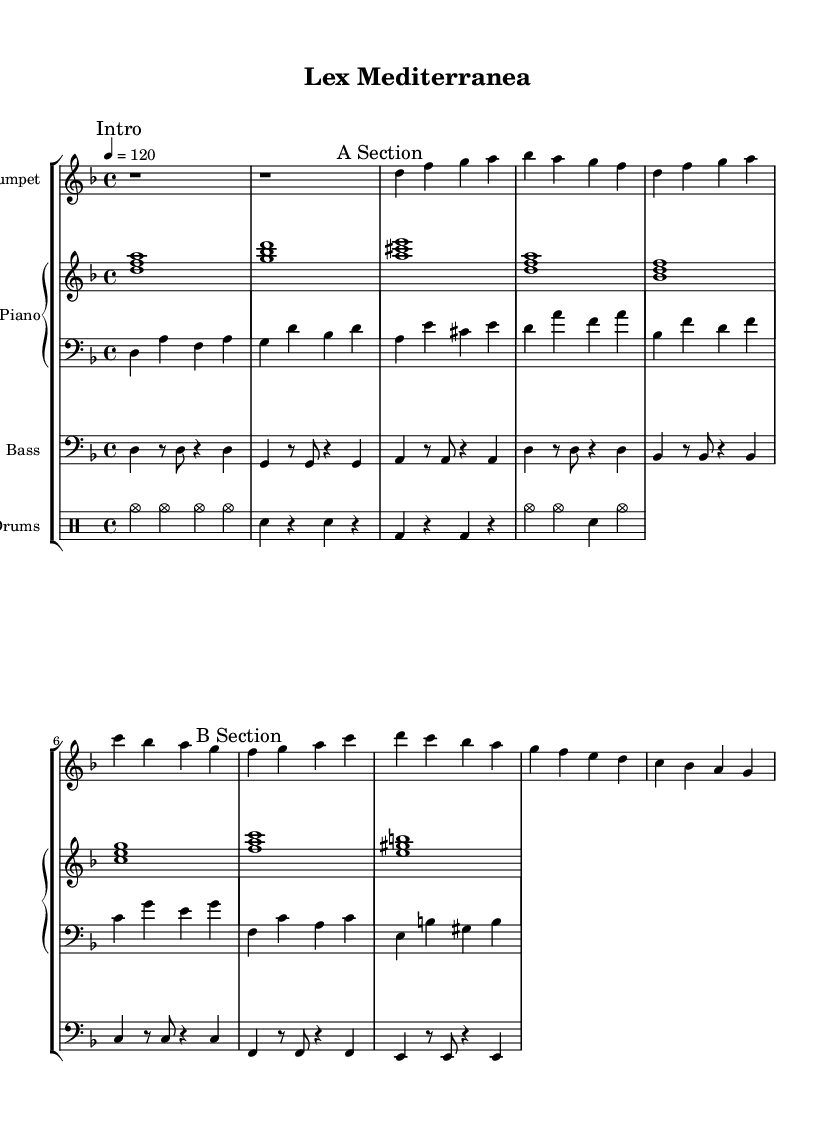What is the key signature of this music? The key signature is indicated by the sharps or flats at the beginning of the staff. In this score, it is determined to be D minor, as there one flat is shown, which corresponds to Bb in D minor.
Answer: D minor What is the time signature of the piece? The time signature is located at the beginning of the score after the key signature. It indicates that there are four beats in each measure, and the quarter note gets one beat. The presence of "4/4" confirms this.
Answer: 4/4 What is the tempo marking for this piece? The tempo marking is found above the staff, stating the speed of the piece. It indicates "4 = 120," which refers to the metronome marking of 120 beats per minute.
Answer: 120 How many measures are there in the A Section? The A Section starts after the intro and consists of a sequence of notes from the first measure labeled with "A Section" through the last measure before the "B Section." Counting these gives us a total of four measures.
Answer: 4 What is the primary rhythm pattern used in the drums part? The drums part uses cymbal hits consistently throughout the measures, indicating a steady rhythm. Notably, the counting of the first measure shows a pattern where cymbals are played on every beat. Thus, it can be described as a steady rhythmic pattern of cymbals and snare hits.
Answer: Steady rhythm Which instrument plays the introductory section? The introductory section, marked as "Intro" at the beginning of the score, is played solely by the trumpet, as indicated by the specific notation and absence of other instrumental parts during this section.
Answer: Trumpet What type of jazz influence is represented in this music? The combination of styles present in the music, particularly the integration of Latin rhythms within a jazz framework, reflects the distinct influence of Mediterranean sounds, which can be deduced from the rhythmic patterns and instrumentation used throughout the piece.
Answer: Fusion jazz 